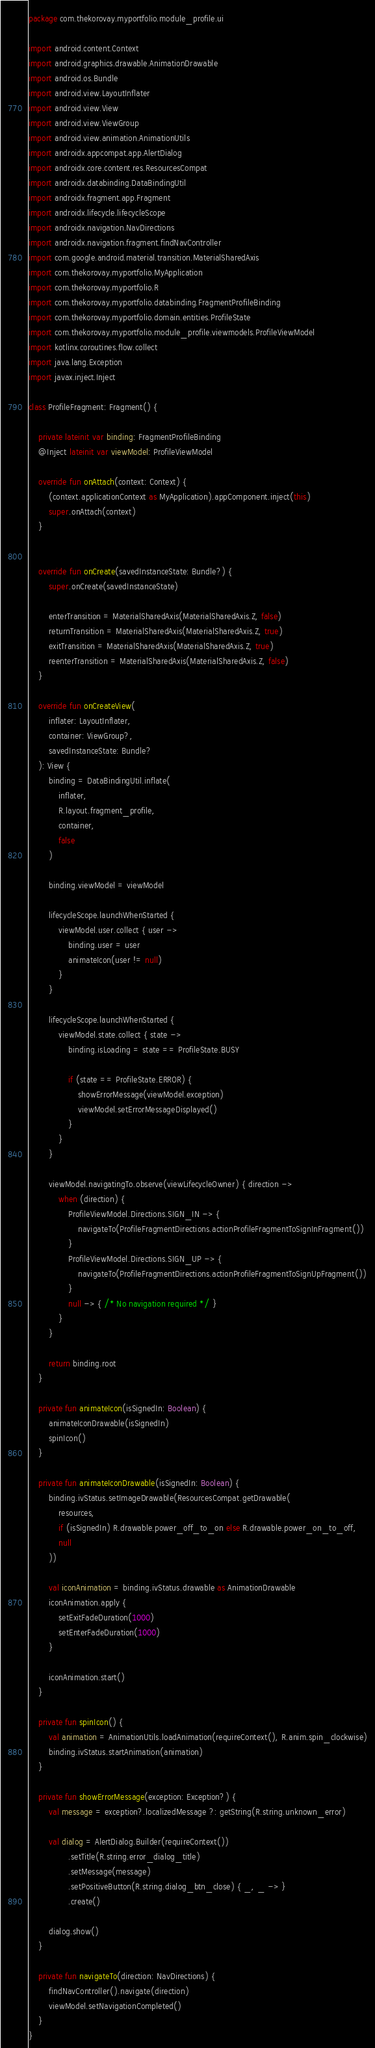<code> <loc_0><loc_0><loc_500><loc_500><_Kotlin_>package com.thekorovay.myportfolio.module_profile.ui

import android.content.Context
import android.graphics.drawable.AnimationDrawable
import android.os.Bundle
import android.view.LayoutInflater
import android.view.View
import android.view.ViewGroup
import android.view.animation.AnimationUtils
import androidx.appcompat.app.AlertDialog
import androidx.core.content.res.ResourcesCompat
import androidx.databinding.DataBindingUtil
import androidx.fragment.app.Fragment
import androidx.lifecycle.lifecycleScope
import androidx.navigation.NavDirections
import androidx.navigation.fragment.findNavController
import com.google.android.material.transition.MaterialSharedAxis
import com.thekorovay.myportfolio.MyApplication
import com.thekorovay.myportfolio.R
import com.thekorovay.myportfolio.databinding.FragmentProfileBinding
import com.thekorovay.myportfolio.domain.entities.ProfileState
import com.thekorovay.myportfolio.module_profile.viewmodels.ProfileViewModel
import kotlinx.coroutines.flow.collect
import java.lang.Exception
import javax.inject.Inject

class ProfileFragment: Fragment() {

    private lateinit var binding: FragmentProfileBinding
    @Inject lateinit var viewModel: ProfileViewModel

    override fun onAttach(context: Context) {
        (context.applicationContext as MyApplication).appComponent.inject(this)
        super.onAttach(context)
    }


    override fun onCreate(savedInstanceState: Bundle?) {
        super.onCreate(savedInstanceState)

        enterTransition = MaterialSharedAxis(MaterialSharedAxis.Z, false)
        returnTransition = MaterialSharedAxis(MaterialSharedAxis.Z, true)
        exitTransition = MaterialSharedAxis(MaterialSharedAxis.Z, true)
        reenterTransition = MaterialSharedAxis(MaterialSharedAxis.Z, false)
    }

    override fun onCreateView(
        inflater: LayoutInflater,
        container: ViewGroup?,
        savedInstanceState: Bundle?
    ): View {
        binding = DataBindingUtil.inflate(
            inflater,
            R.layout.fragment_profile,
            container,
            false
        )

        binding.viewModel = viewModel

        lifecycleScope.launchWhenStarted {
            viewModel.user.collect { user ->
                binding.user = user
                animateIcon(user != null)
            }
        }

        lifecycleScope.launchWhenStarted {
            viewModel.state.collect { state ->
                binding.isLoading = state == ProfileState.BUSY

                if (state == ProfileState.ERROR) {
                    showErrorMessage(viewModel.exception)
                    viewModel.setErrorMessageDisplayed()
                }
            }
        }

        viewModel.navigatingTo.observe(viewLifecycleOwner) { direction ->
            when (direction) {
                ProfileViewModel.Directions.SIGN_IN -> {
                    navigateTo(ProfileFragmentDirections.actionProfileFragmentToSignInFragment())
                }
                ProfileViewModel.Directions.SIGN_UP -> {
                    navigateTo(ProfileFragmentDirections.actionProfileFragmentToSignUpFragment())
                }
                null -> { /* No navigation required */ }
            }
        }

        return binding.root
    }

    private fun animateIcon(isSignedIn: Boolean) {
        animateIconDrawable(isSignedIn)
        spinIcon()
    }

    private fun animateIconDrawable(isSignedIn: Boolean) {
        binding.ivStatus.setImageDrawable(ResourcesCompat.getDrawable(
            resources,
            if (isSignedIn) R.drawable.power_off_to_on else R.drawable.power_on_to_off,
            null
        ))

        val iconAnimation = binding.ivStatus.drawable as AnimationDrawable
        iconAnimation.apply {
            setExitFadeDuration(1000)
            setEnterFadeDuration(1000)
        }

        iconAnimation.start()
    }

    private fun spinIcon() {
        val animation = AnimationUtils.loadAnimation(requireContext(), R.anim.spin_clockwise)
        binding.ivStatus.startAnimation(animation)
    }

    private fun showErrorMessage(exception: Exception?) {
        val message = exception?.localizedMessage ?: getString(R.string.unknown_error)

        val dialog = AlertDialog.Builder(requireContext())
                .setTitle(R.string.error_dialog_title)
                .setMessage(message)
                .setPositiveButton(R.string.dialog_btn_close) { _, _ -> }
                .create()

        dialog.show()
    }

    private fun navigateTo(direction: NavDirections) {
        findNavController().navigate(direction)
        viewModel.setNavigationCompleted()
    }
}</code> 